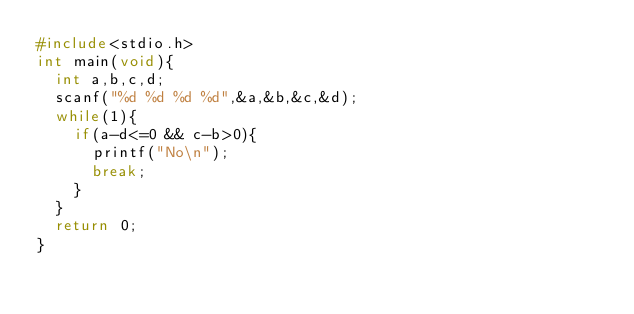<code> <loc_0><loc_0><loc_500><loc_500><_C_>#include<stdio.h>
int main(void){
  int a,b,c,d;
  scanf("%d %d %d %d",&a,&b,&c,&d);
  while(1){
    if(a-d<=0 && c-b>0){
      printf("No\n");
      break;
    }
  }
  return 0;
}</code> 